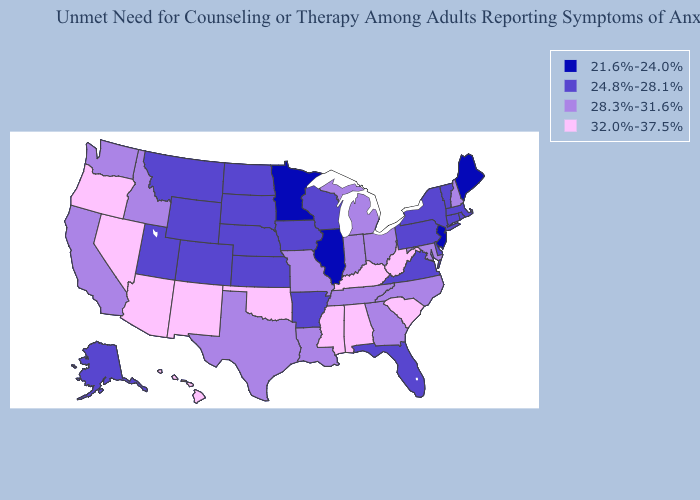What is the value of Mississippi?
Concise answer only. 32.0%-37.5%. Among the states that border New Mexico , which have the highest value?
Write a very short answer. Arizona, Oklahoma. What is the value of Minnesota?
Quick response, please. 21.6%-24.0%. Name the states that have a value in the range 21.6%-24.0%?
Quick response, please. Illinois, Maine, Minnesota, New Jersey. Which states have the lowest value in the USA?
Answer briefly. Illinois, Maine, Minnesota, New Jersey. Which states have the lowest value in the USA?
Write a very short answer. Illinois, Maine, Minnesota, New Jersey. What is the lowest value in the South?
Quick response, please. 24.8%-28.1%. Which states hav the highest value in the West?
Keep it brief. Arizona, Hawaii, Nevada, New Mexico, Oregon. What is the highest value in the MidWest ?
Write a very short answer. 28.3%-31.6%. Name the states that have a value in the range 32.0%-37.5%?
Quick response, please. Alabama, Arizona, Hawaii, Kentucky, Mississippi, Nevada, New Mexico, Oklahoma, Oregon, South Carolina, West Virginia. What is the lowest value in the USA?
Write a very short answer. 21.6%-24.0%. What is the value of Arizona?
Answer briefly. 32.0%-37.5%. Does Vermont have the highest value in the Northeast?
Be succinct. No. What is the value of Tennessee?
Answer briefly. 28.3%-31.6%. 